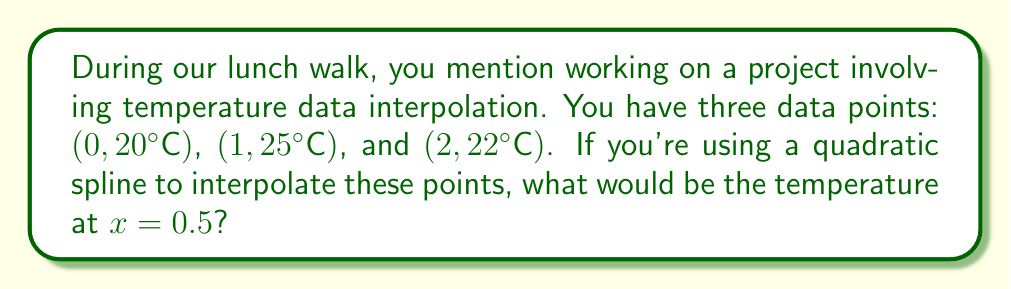What is the answer to this math problem? Let's approach this step-by-step:

1) A quadratic spline for these three points will consist of two quadratic functions:
   $S_1(x)$ for $0 \leq x \leq 1$ and $S_2(x)$ for $1 \leq x \leq 2$

2) The general form of a quadratic function is $ax^2 + bx + c$. So we have:
   $S_1(x) = a_1x^2 + b_1x + c_1$
   $S_2(x) = a_2x^2 + b_2x + c_2$

3) We need to satisfy these conditions:
   $S_1(0) = 20$
   $S_1(1) = S_2(1) = 25$
   $S_2(2) = 22$
   $S_1'(1) = S_2'(1)$ (smooth transition)

4) From $S_1(0) = 20$, we get $c_1 = 20$

5) From $S_1(1) = 25$, we get $a_1 + b_1 + 20 = 25$

6) From $S_2(2) = 22$, we get $4a_2 + 2b_2 + c_2 = 22$

7) From $S_1(1) = S_2(1)$, we get $a_1 + b_1 + 20 = a_2 + b_2 + c_2 = 25$

8) From $S_1'(1) = S_2'(1)$, we get $2a_1 + b_1 = 2a_2 + b_2$

9) We need one more equation. Let's use the fact that the second derivative is constant for each piece:
   $S_1''(x) = 2a_1$ and $S_2''(x) = 2a_2$
   If we make these equal: $a_1 = a_2 = a$

10) Now we have enough equations to solve. After some algebra:
    $a = -3$, $b_1 = 8$, $c_1 = 20$

11) Therefore, $S_1(x) = -3x^2 + 8x + 20$

12) To find the temperature at $x = 0.5$, we calculate:
    $S_1(0.5) = -3(0.5)^2 + 8(0.5) + 20$
               $= -0.75 + 4 + 20$
               $= 23.25$
Answer: 23.25°C 